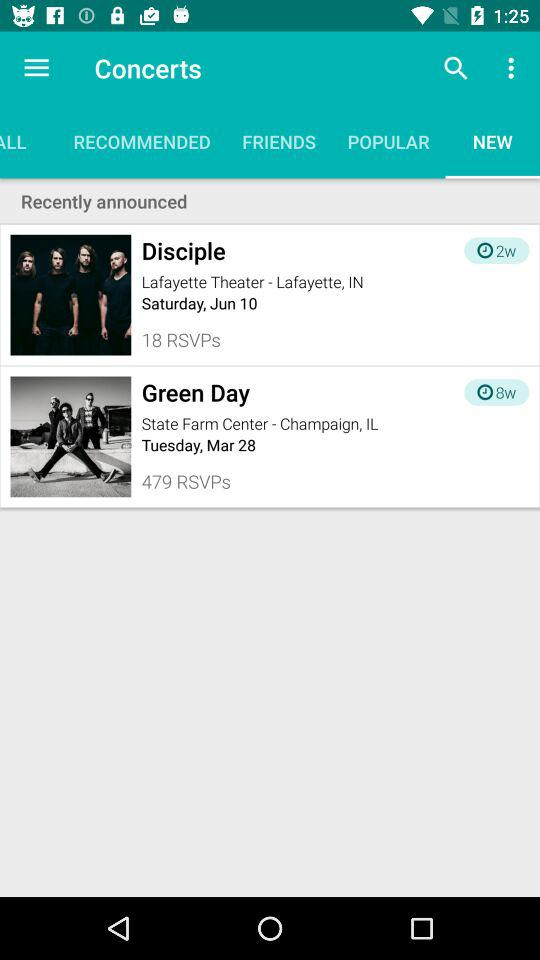What is the location of the concert "Disciple"? The location of the concert "Disciple" is the Lafayette Theater in Lafayette, IN. 